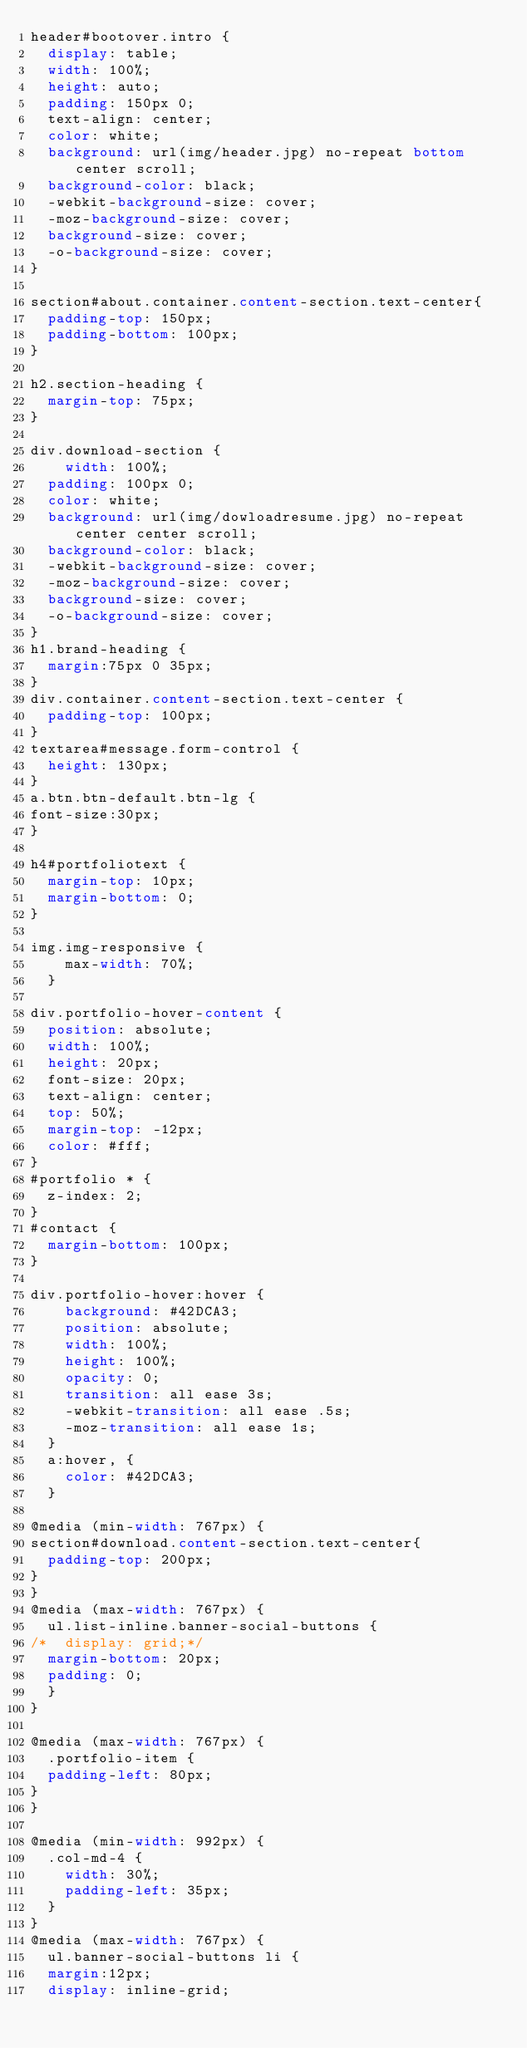Convert code to text. <code><loc_0><loc_0><loc_500><loc_500><_CSS_>header#bootover.intro {
  display: table;
  width: 100%;
  height: auto;
  padding: 150px 0;
  text-align: center;
  color: white;
  background: url(img/header.jpg) no-repeat bottom center scroll;
  background-color: black;
  -webkit-background-size: cover;
  -moz-background-size: cover;
  background-size: cover;
  -o-background-size: cover;
}

section#about.container.content-section.text-center{
  padding-top: 150px;
  padding-bottom: 100px;
}

h2.section-heading {
  margin-top: 75px;
}

div.download-section {
    width: 100%;
  padding: 100px 0;
  color: white;
  background: url(img/dowloadresume.jpg) no-repeat center center scroll;
  background-color: black;
  -webkit-background-size: cover;
  -moz-background-size: cover;
  background-size: cover;
  -o-background-size: cover;
}
h1.brand-heading {
  margin:75px 0 35px;
}
div.container.content-section.text-center {
  padding-top: 100px;
}
textarea#message.form-control {
  height: 130px;
}
a.btn.btn-default.btn-lg {
font-size:30px;
}

h4#portfoliotext {
  margin-top: 10px;
  margin-bottom: 0;
}

img.img-responsive {
    max-width: 70%;
  }

div.portfolio-hover-content {
  position: absolute;
  width: 100%;
  height: 20px;
  font-size: 20px;
  text-align: center;
  top: 50%;
  margin-top: -12px;
  color: #fff;
}
#portfolio * {
  z-index: 2;
}
#contact {
  margin-bottom: 100px;
} 

div.portfolio-hover:hover {
    background: #42DCA3;
    position: absolute;
    width: 100%;
    height: 100%;
    opacity: 0;
    transition: all ease 3s;
    -webkit-transition: all ease .5s;
    -moz-transition: all ease 1s;
  }
  a:hover, {
    color: #42DCA3;
  }

@media (min-width: 767px) {
section#download.content-section.text-center{
  padding-top: 200px;
}
}
@media (max-width: 767px) {
  ul.list-inline.banner-social-buttons {
/*  display: grid;*/
  margin-bottom: 20px;
  padding: 0;
  }
}

@media (max-width: 767px) {
  .portfolio-item {
  padding-left: 80px;
}
}

@media (min-width: 992px) {
  .col-md-4 {
    width: 30%;
    padding-left: 35px;
  }
}
@media (max-width: 767px) {
  ul.banner-social-buttons li {
  margin:12px;
  display: inline-grid;</code> 